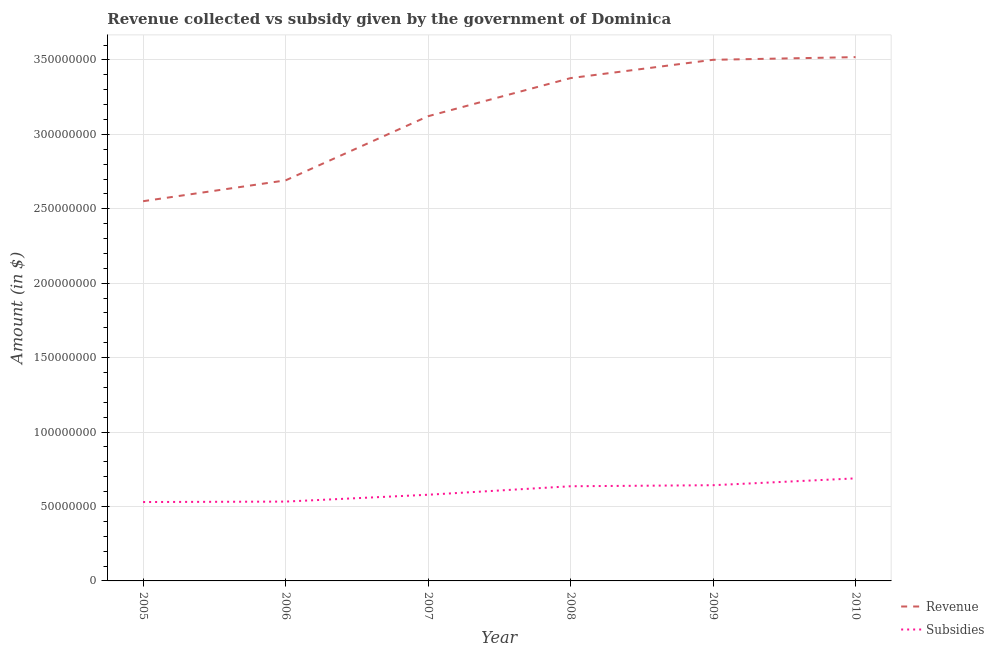How many different coloured lines are there?
Make the answer very short. 2. Does the line corresponding to amount of subsidies given intersect with the line corresponding to amount of revenue collected?
Your response must be concise. No. Is the number of lines equal to the number of legend labels?
Offer a very short reply. Yes. What is the amount of revenue collected in 2010?
Provide a succinct answer. 3.52e+08. Across all years, what is the maximum amount of revenue collected?
Provide a succinct answer. 3.52e+08. Across all years, what is the minimum amount of subsidies given?
Give a very brief answer. 5.30e+07. In which year was the amount of revenue collected maximum?
Your answer should be compact. 2010. In which year was the amount of revenue collected minimum?
Offer a very short reply. 2005. What is the total amount of revenue collected in the graph?
Offer a very short reply. 1.88e+09. What is the difference between the amount of subsidies given in 2005 and that in 2009?
Provide a succinct answer. -1.13e+07. What is the difference between the amount of subsidies given in 2009 and the amount of revenue collected in 2008?
Your answer should be very brief. -2.74e+08. What is the average amount of revenue collected per year?
Your response must be concise. 3.13e+08. In the year 2005, what is the difference between the amount of revenue collected and amount of subsidies given?
Your answer should be compact. 2.02e+08. In how many years, is the amount of revenue collected greater than 70000000 $?
Your answer should be very brief. 6. What is the ratio of the amount of subsidies given in 2005 to that in 2010?
Provide a short and direct response. 0.77. What is the difference between the highest and the second highest amount of revenue collected?
Offer a very short reply. 1.80e+06. What is the difference between the highest and the lowest amount of revenue collected?
Give a very brief answer. 9.68e+07. Is the sum of the amount of subsidies given in 2005 and 2007 greater than the maximum amount of revenue collected across all years?
Ensure brevity in your answer.  No. Does the amount of subsidies given monotonically increase over the years?
Make the answer very short. Yes. How many years are there in the graph?
Offer a terse response. 6. What is the difference between two consecutive major ticks on the Y-axis?
Your answer should be very brief. 5.00e+07. Where does the legend appear in the graph?
Your answer should be compact. Bottom right. How are the legend labels stacked?
Provide a short and direct response. Vertical. What is the title of the graph?
Provide a succinct answer. Revenue collected vs subsidy given by the government of Dominica. What is the label or title of the Y-axis?
Offer a terse response. Amount (in $). What is the Amount (in $) in Revenue in 2005?
Provide a succinct answer. 2.55e+08. What is the Amount (in $) of Subsidies in 2005?
Provide a short and direct response. 5.30e+07. What is the Amount (in $) of Revenue in 2006?
Make the answer very short. 2.69e+08. What is the Amount (in $) in Subsidies in 2006?
Provide a short and direct response. 5.33e+07. What is the Amount (in $) in Revenue in 2007?
Your response must be concise. 3.12e+08. What is the Amount (in $) of Subsidies in 2007?
Offer a very short reply. 5.79e+07. What is the Amount (in $) of Revenue in 2008?
Ensure brevity in your answer.  3.38e+08. What is the Amount (in $) in Subsidies in 2008?
Offer a very short reply. 6.36e+07. What is the Amount (in $) of Revenue in 2009?
Make the answer very short. 3.50e+08. What is the Amount (in $) in Subsidies in 2009?
Make the answer very short. 6.43e+07. What is the Amount (in $) in Revenue in 2010?
Provide a short and direct response. 3.52e+08. What is the Amount (in $) of Subsidies in 2010?
Provide a short and direct response. 6.89e+07. Across all years, what is the maximum Amount (in $) in Revenue?
Keep it short and to the point. 3.52e+08. Across all years, what is the maximum Amount (in $) of Subsidies?
Your answer should be very brief. 6.89e+07. Across all years, what is the minimum Amount (in $) in Revenue?
Provide a short and direct response. 2.55e+08. Across all years, what is the minimum Amount (in $) in Subsidies?
Your answer should be compact. 5.30e+07. What is the total Amount (in $) of Revenue in the graph?
Make the answer very short. 1.88e+09. What is the total Amount (in $) of Subsidies in the graph?
Offer a very short reply. 3.61e+08. What is the difference between the Amount (in $) of Revenue in 2005 and that in 2006?
Make the answer very short. -1.40e+07. What is the difference between the Amount (in $) in Revenue in 2005 and that in 2007?
Give a very brief answer. -5.71e+07. What is the difference between the Amount (in $) in Subsidies in 2005 and that in 2007?
Provide a succinct answer. -4.90e+06. What is the difference between the Amount (in $) in Revenue in 2005 and that in 2008?
Offer a terse response. -8.27e+07. What is the difference between the Amount (in $) of Subsidies in 2005 and that in 2008?
Keep it short and to the point. -1.06e+07. What is the difference between the Amount (in $) in Revenue in 2005 and that in 2009?
Your answer should be very brief. -9.50e+07. What is the difference between the Amount (in $) in Subsidies in 2005 and that in 2009?
Your answer should be compact. -1.13e+07. What is the difference between the Amount (in $) of Revenue in 2005 and that in 2010?
Keep it short and to the point. -9.68e+07. What is the difference between the Amount (in $) of Subsidies in 2005 and that in 2010?
Ensure brevity in your answer.  -1.59e+07. What is the difference between the Amount (in $) of Revenue in 2006 and that in 2007?
Offer a very short reply. -4.31e+07. What is the difference between the Amount (in $) of Subsidies in 2006 and that in 2007?
Offer a terse response. -4.60e+06. What is the difference between the Amount (in $) of Revenue in 2006 and that in 2008?
Offer a very short reply. -6.87e+07. What is the difference between the Amount (in $) of Subsidies in 2006 and that in 2008?
Make the answer very short. -1.03e+07. What is the difference between the Amount (in $) in Revenue in 2006 and that in 2009?
Keep it short and to the point. -8.10e+07. What is the difference between the Amount (in $) in Subsidies in 2006 and that in 2009?
Give a very brief answer. -1.10e+07. What is the difference between the Amount (in $) in Revenue in 2006 and that in 2010?
Offer a very short reply. -8.28e+07. What is the difference between the Amount (in $) of Subsidies in 2006 and that in 2010?
Your response must be concise. -1.56e+07. What is the difference between the Amount (in $) in Revenue in 2007 and that in 2008?
Offer a terse response. -2.56e+07. What is the difference between the Amount (in $) in Subsidies in 2007 and that in 2008?
Offer a terse response. -5.70e+06. What is the difference between the Amount (in $) in Revenue in 2007 and that in 2009?
Ensure brevity in your answer.  -3.79e+07. What is the difference between the Amount (in $) in Subsidies in 2007 and that in 2009?
Ensure brevity in your answer.  -6.40e+06. What is the difference between the Amount (in $) in Revenue in 2007 and that in 2010?
Make the answer very short. -3.97e+07. What is the difference between the Amount (in $) in Subsidies in 2007 and that in 2010?
Keep it short and to the point. -1.10e+07. What is the difference between the Amount (in $) in Revenue in 2008 and that in 2009?
Provide a succinct answer. -1.23e+07. What is the difference between the Amount (in $) of Subsidies in 2008 and that in 2009?
Offer a terse response. -7.00e+05. What is the difference between the Amount (in $) in Revenue in 2008 and that in 2010?
Your answer should be compact. -1.41e+07. What is the difference between the Amount (in $) of Subsidies in 2008 and that in 2010?
Offer a terse response. -5.30e+06. What is the difference between the Amount (in $) of Revenue in 2009 and that in 2010?
Your answer should be compact. -1.80e+06. What is the difference between the Amount (in $) in Subsidies in 2009 and that in 2010?
Provide a succinct answer. -4.60e+06. What is the difference between the Amount (in $) of Revenue in 2005 and the Amount (in $) of Subsidies in 2006?
Ensure brevity in your answer.  2.02e+08. What is the difference between the Amount (in $) in Revenue in 2005 and the Amount (in $) in Subsidies in 2007?
Offer a very short reply. 1.97e+08. What is the difference between the Amount (in $) of Revenue in 2005 and the Amount (in $) of Subsidies in 2008?
Provide a short and direct response. 1.92e+08. What is the difference between the Amount (in $) in Revenue in 2005 and the Amount (in $) in Subsidies in 2009?
Make the answer very short. 1.91e+08. What is the difference between the Amount (in $) of Revenue in 2005 and the Amount (in $) of Subsidies in 2010?
Provide a short and direct response. 1.86e+08. What is the difference between the Amount (in $) of Revenue in 2006 and the Amount (in $) of Subsidies in 2007?
Your answer should be compact. 2.11e+08. What is the difference between the Amount (in $) of Revenue in 2006 and the Amount (in $) of Subsidies in 2008?
Provide a succinct answer. 2.06e+08. What is the difference between the Amount (in $) in Revenue in 2006 and the Amount (in $) in Subsidies in 2009?
Provide a succinct answer. 2.05e+08. What is the difference between the Amount (in $) of Revenue in 2006 and the Amount (in $) of Subsidies in 2010?
Your answer should be compact. 2.00e+08. What is the difference between the Amount (in $) in Revenue in 2007 and the Amount (in $) in Subsidies in 2008?
Offer a very short reply. 2.49e+08. What is the difference between the Amount (in $) in Revenue in 2007 and the Amount (in $) in Subsidies in 2009?
Offer a terse response. 2.48e+08. What is the difference between the Amount (in $) in Revenue in 2007 and the Amount (in $) in Subsidies in 2010?
Your answer should be compact. 2.43e+08. What is the difference between the Amount (in $) of Revenue in 2008 and the Amount (in $) of Subsidies in 2009?
Ensure brevity in your answer.  2.74e+08. What is the difference between the Amount (in $) in Revenue in 2008 and the Amount (in $) in Subsidies in 2010?
Your answer should be compact. 2.69e+08. What is the difference between the Amount (in $) in Revenue in 2009 and the Amount (in $) in Subsidies in 2010?
Your response must be concise. 2.81e+08. What is the average Amount (in $) in Revenue per year?
Ensure brevity in your answer.  3.13e+08. What is the average Amount (in $) in Subsidies per year?
Ensure brevity in your answer.  6.02e+07. In the year 2005, what is the difference between the Amount (in $) in Revenue and Amount (in $) in Subsidies?
Provide a short and direct response. 2.02e+08. In the year 2006, what is the difference between the Amount (in $) in Revenue and Amount (in $) in Subsidies?
Provide a succinct answer. 2.16e+08. In the year 2007, what is the difference between the Amount (in $) of Revenue and Amount (in $) of Subsidies?
Give a very brief answer. 2.54e+08. In the year 2008, what is the difference between the Amount (in $) of Revenue and Amount (in $) of Subsidies?
Make the answer very short. 2.74e+08. In the year 2009, what is the difference between the Amount (in $) in Revenue and Amount (in $) in Subsidies?
Your answer should be compact. 2.86e+08. In the year 2010, what is the difference between the Amount (in $) of Revenue and Amount (in $) of Subsidies?
Make the answer very short. 2.83e+08. What is the ratio of the Amount (in $) of Revenue in 2005 to that in 2006?
Provide a succinct answer. 0.95. What is the ratio of the Amount (in $) in Subsidies in 2005 to that in 2006?
Give a very brief answer. 0.99. What is the ratio of the Amount (in $) of Revenue in 2005 to that in 2007?
Keep it short and to the point. 0.82. What is the ratio of the Amount (in $) of Subsidies in 2005 to that in 2007?
Keep it short and to the point. 0.92. What is the ratio of the Amount (in $) of Revenue in 2005 to that in 2008?
Your answer should be compact. 0.76. What is the ratio of the Amount (in $) of Subsidies in 2005 to that in 2008?
Ensure brevity in your answer.  0.83. What is the ratio of the Amount (in $) of Revenue in 2005 to that in 2009?
Your answer should be very brief. 0.73. What is the ratio of the Amount (in $) of Subsidies in 2005 to that in 2009?
Offer a very short reply. 0.82. What is the ratio of the Amount (in $) in Revenue in 2005 to that in 2010?
Your answer should be compact. 0.72. What is the ratio of the Amount (in $) of Subsidies in 2005 to that in 2010?
Your answer should be very brief. 0.77. What is the ratio of the Amount (in $) of Revenue in 2006 to that in 2007?
Your answer should be compact. 0.86. What is the ratio of the Amount (in $) of Subsidies in 2006 to that in 2007?
Offer a very short reply. 0.92. What is the ratio of the Amount (in $) in Revenue in 2006 to that in 2008?
Provide a short and direct response. 0.8. What is the ratio of the Amount (in $) in Subsidies in 2006 to that in 2008?
Your answer should be compact. 0.84. What is the ratio of the Amount (in $) in Revenue in 2006 to that in 2009?
Ensure brevity in your answer.  0.77. What is the ratio of the Amount (in $) in Subsidies in 2006 to that in 2009?
Your response must be concise. 0.83. What is the ratio of the Amount (in $) of Revenue in 2006 to that in 2010?
Your answer should be very brief. 0.76. What is the ratio of the Amount (in $) of Subsidies in 2006 to that in 2010?
Offer a terse response. 0.77. What is the ratio of the Amount (in $) in Revenue in 2007 to that in 2008?
Keep it short and to the point. 0.92. What is the ratio of the Amount (in $) in Subsidies in 2007 to that in 2008?
Your answer should be very brief. 0.91. What is the ratio of the Amount (in $) of Revenue in 2007 to that in 2009?
Your answer should be very brief. 0.89. What is the ratio of the Amount (in $) of Subsidies in 2007 to that in 2009?
Offer a terse response. 0.9. What is the ratio of the Amount (in $) in Revenue in 2007 to that in 2010?
Provide a succinct answer. 0.89. What is the ratio of the Amount (in $) in Subsidies in 2007 to that in 2010?
Make the answer very short. 0.84. What is the ratio of the Amount (in $) of Revenue in 2008 to that in 2009?
Ensure brevity in your answer.  0.96. What is the ratio of the Amount (in $) of Subsidies in 2008 to that in 2009?
Make the answer very short. 0.99. What is the ratio of the Amount (in $) of Revenue in 2008 to that in 2010?
Provide a short and direct response. 0.96. What is the ratio of the Amount (in $) in Subsidies in 2008 to that in 2010?
Offer a terse response. 0.92. What is the ratio of the Amount (in $) in Subsidies in 2009 to that in 2010?
Your answer should be very brief. 0.93. What is the difference between the highest and the second highest Amount (in $) in Revenue?
Offer a terse response. 1.80e+06. What is the difference between the highest and the second highest Amount (in $) in Subsidies?
Your response must be concise. 4.60e+06. What is the difference between the highest and the lowest Amount (in $) of Revenue?
Your response must be concise. 9.68e+07. What is the difference between the highest and the lowest Amount (in $) in Subsidies?
Make the answer very short. 1.59e+07. 